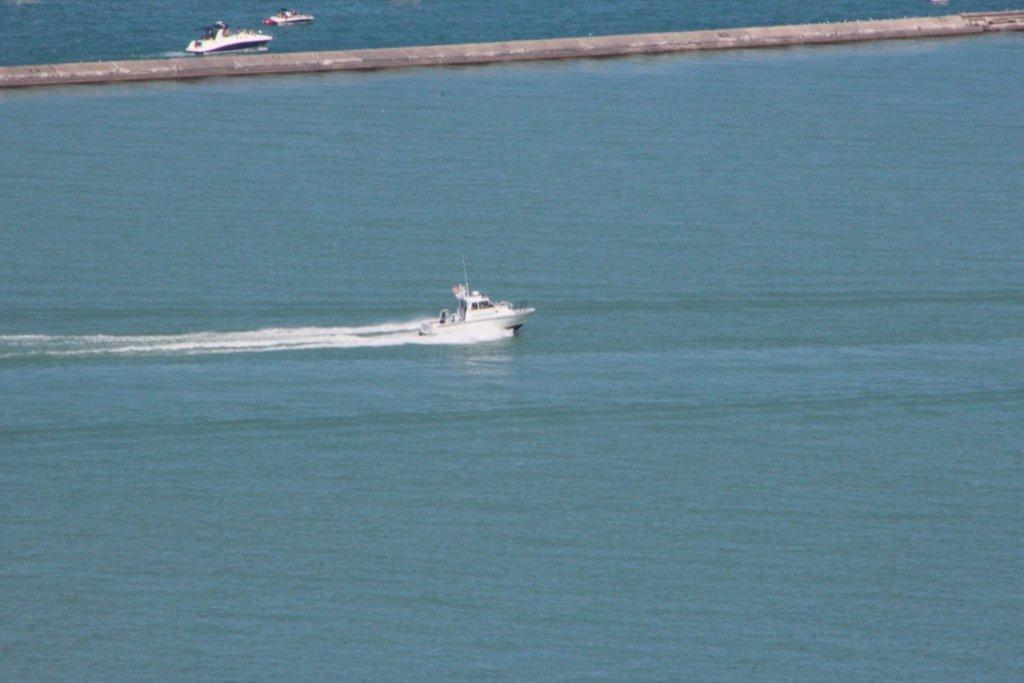What type of vehicles are present in the image? There are boats in the image. Where are the boats located? The boats are in a large water body. What additional structure can be seen in the image? There is a walkway bridge visible in the image. What type of chin is visible on the boats in the image? There is no chin present on the boats in the image, as boats do not have chins. 